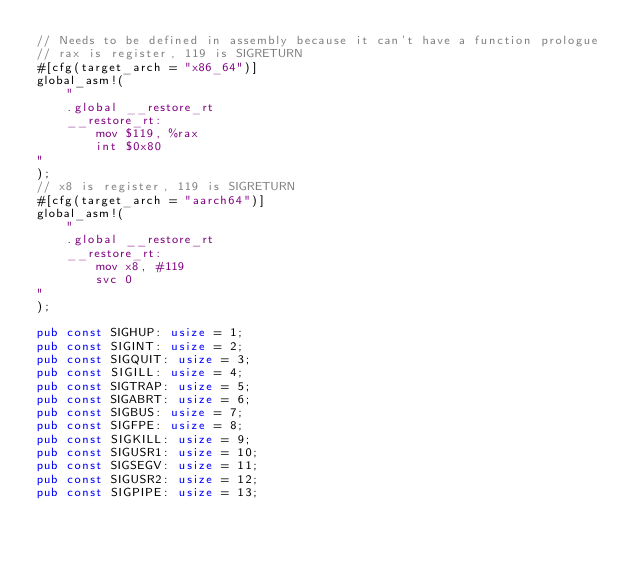<code> <loc_0><loc_0><loc_500><loc_500><_Rust_>// Needs to be defined in assembly because it can't have a function prologue
// rax is register, 119 is SIGRETURN
#[cfg(target_arch = "x86_64")]
global_asm!(
    "
    .global __restore_rt
    __restore_rt:
        mov $119, %rax
        int $0x80
"
);
// x8 is register, 119 is SIGRETURN
#[cfg(target_arch = "aarch64")]
global_asm!(
    "
    .global __restore_rt
    __restore_rt:
        mov x8, #119
        svc 0
"
);

pub const SIGHUP: usize = 1;
pub const SIGINT: usize = 2;
pub const SIGQUIT: usize = 3;
pub const SIGILL: usize = 4;
pub const SIGTRAP: usize = 5;
pub const SIGABRT: usize = 6;
pub const SIGBUS: usize = 7;
pub const SIGFPE: usize = 8;
pub const SIGKILL: usize = 9;
pub const SIGUSR1: usize = 10;
pub const SIGSEGV: usize = 11;
pub const SIGUSR2: usize = 12;
pub const SIGPIPE: usize = 13;</code> 